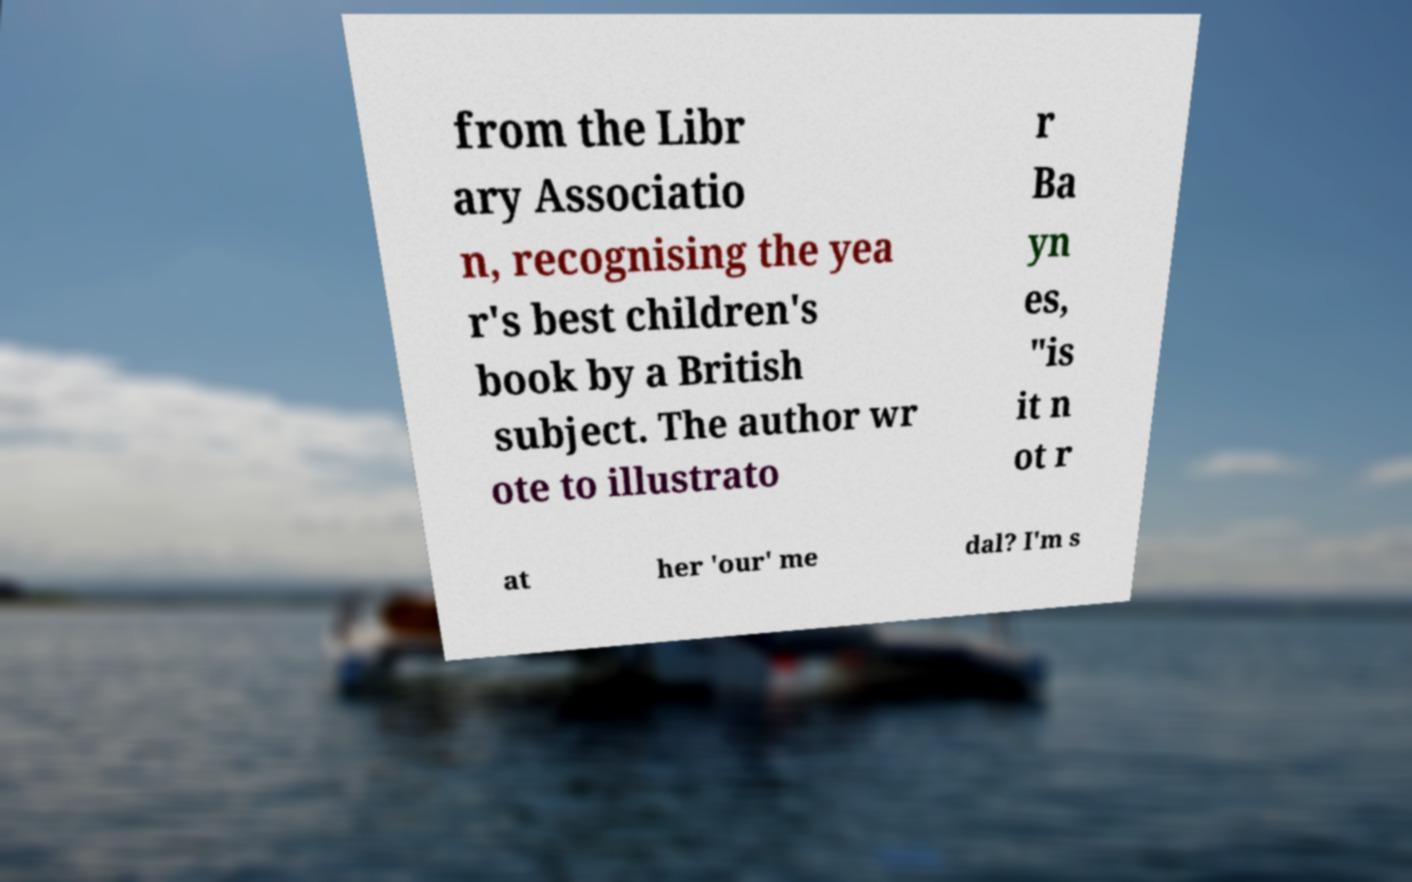What messages or text are displayed in this image? I need them in a readable, typed format. from the Libr ary Associatio n, recognising the yea r's best children's book by a British subject. The author wr ote to illustrato r Ba yn es, "is it n ot r at her 'our' me dal? I'm s 